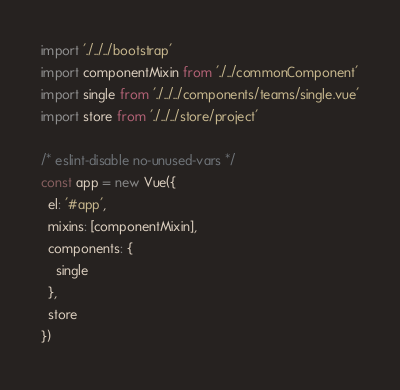<code> <loc_0><loc_0><loc_500><loc_500><_JavaScript_>import './../../bootstrap'
import componentMixin from './../commonComponent'
import single from './../../components/teams/single.vue'
import store from './../../store/project'

/* eslint-disable no-unused-vars */
const app = new Vue({
  el: '#app',
  mixins: [componentMixin],
  components: {
    single
  },
  store
})
</code> 